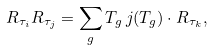<formula> <loc_0><loc_0><loc_500><loc_500>R _ { \tau _ { i } } R _ { \tau _ { j } } = \sum _ { g } T _ { g } \, j ( T _ { g } ) \cdot R _ { \tau _ { k } } ,</formula> 